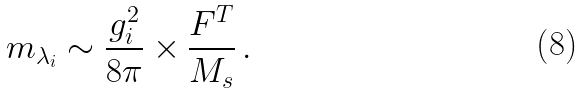Convert formula to latex. <formula><loc_0><loc_0><loc_500><loc_500>m _ { \lambda _ { i } } \sim \frac { g _ { i } ^ { 2 } } { 8 \pi } \times \frac { F ^ { T } } { M _ { s } } \, .</formula> 